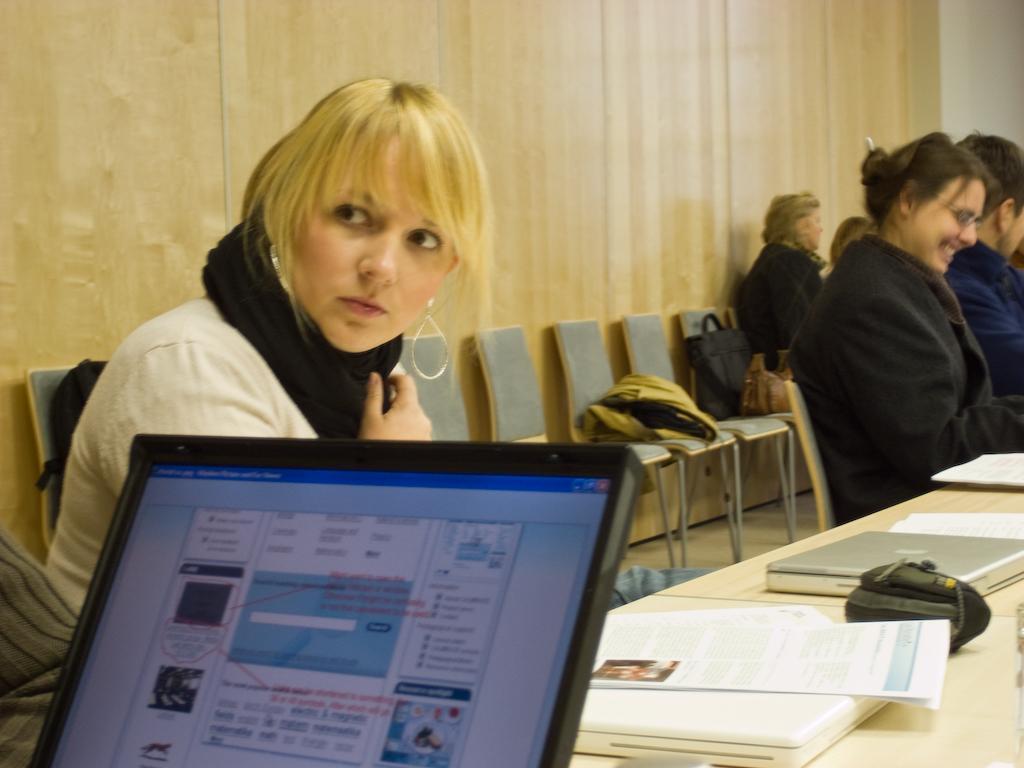In one or two sentences, can you explain what this image depicts? In this image I see few people who are sitting on chairs and there are few bags on the chairs too. I can see that this woman is smiling, I can also see that there are table on which there are laptops and the papers. In the background I see the wall. 